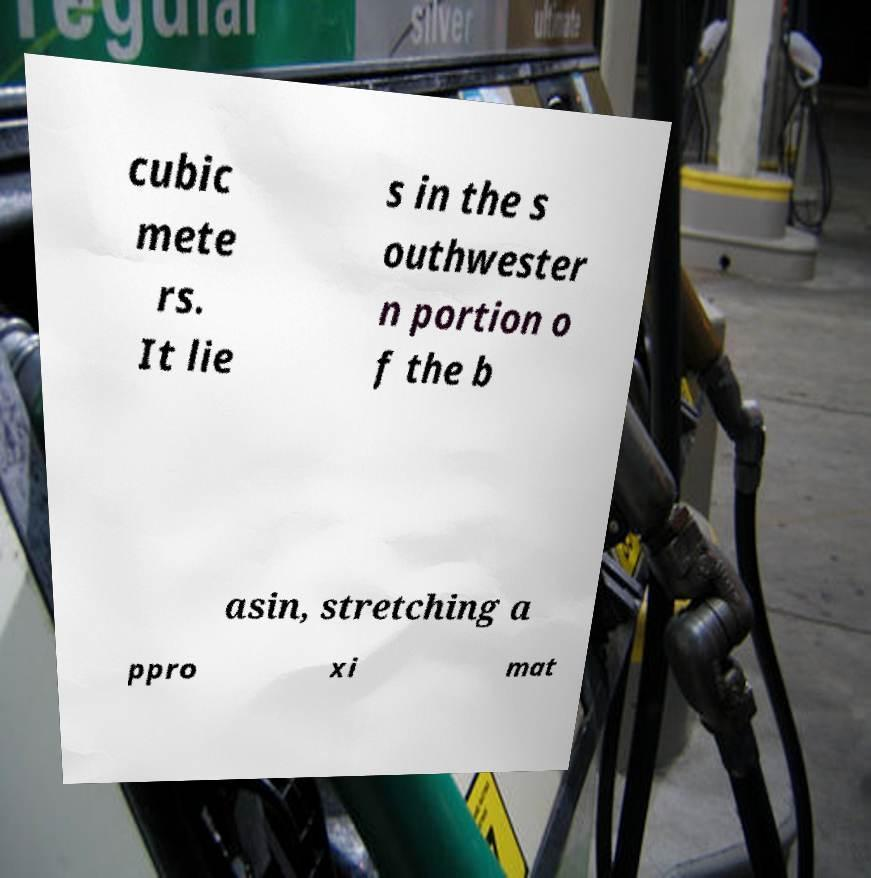There's text embedded in this image that I need extracted. Can you transcribe it verbatim? cubic mete rs. It lie s in the s outhwester n portion o f the b asin, stretching a ppro xi mat 